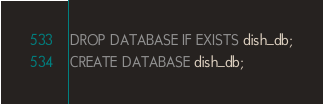Convert code to text. <code><loc_0><loc_0><loc_500><loc_500><_SQL_>DROP DATABASE IF EXISTS dish_db;
CREATE DATABASE dish_db;</code> 